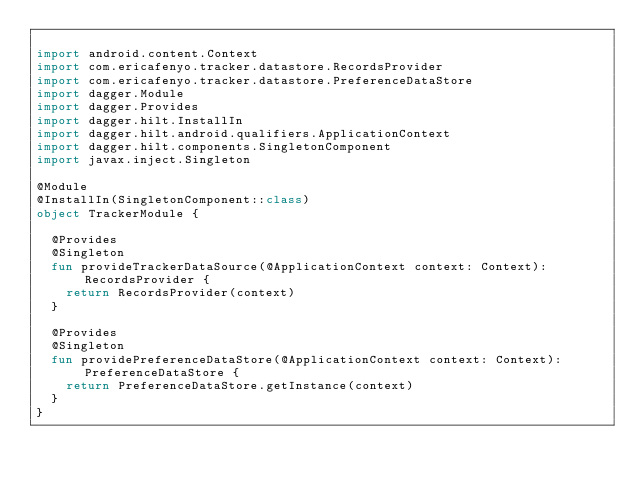Convert code to text. <code><loc_0><loc_0><loc_500><loc_500><_Kotlin_>
import android.content.Context
import com.ericafenyo.tracker.datastore.RecordsProvider
import com.ericafenyo.tracker.datastore.PreferenceDataStore
import dagger.Module
import dagger.Provides
import dagger.hilt.InstallIn
import dagger.hilt.android.qualifiers.ApplicationContext
import dagger.hilt.components.SingletonComponent
import javax.inject.Singleton

@Module
@InstallIn(SingletonComponent::class)
object TrackerModule {

  @Provides
  @Singleton
  fun provideTrackerDataSource(@ApplicationContext context: Context): RecordsProvider {
    return RecordsProvider(context)
  }

  @Provides
  @Singleton
  fun providePreferenceDataStore(@ApplicationContext context: Context): PreferenceDataStore {
    return PreferenceDataStore.getInstance(context)
  }
}
</code> 